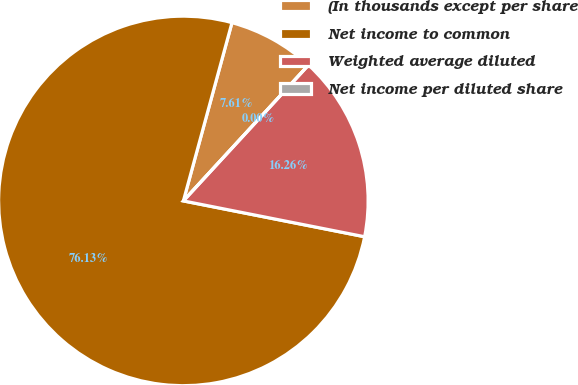Convert chart. <chart><loc_0><loc_0><loc_500><loc_500><pie_chart><fcel>(In thousands except per share<fcel>Net income to common<fcel>Weighted average diluted<fcel>Net income per diluted share<nl><fcel>7.61%<fcel>76.13%<fcel>16.26%<fcel>0.0%<nl></chart> 